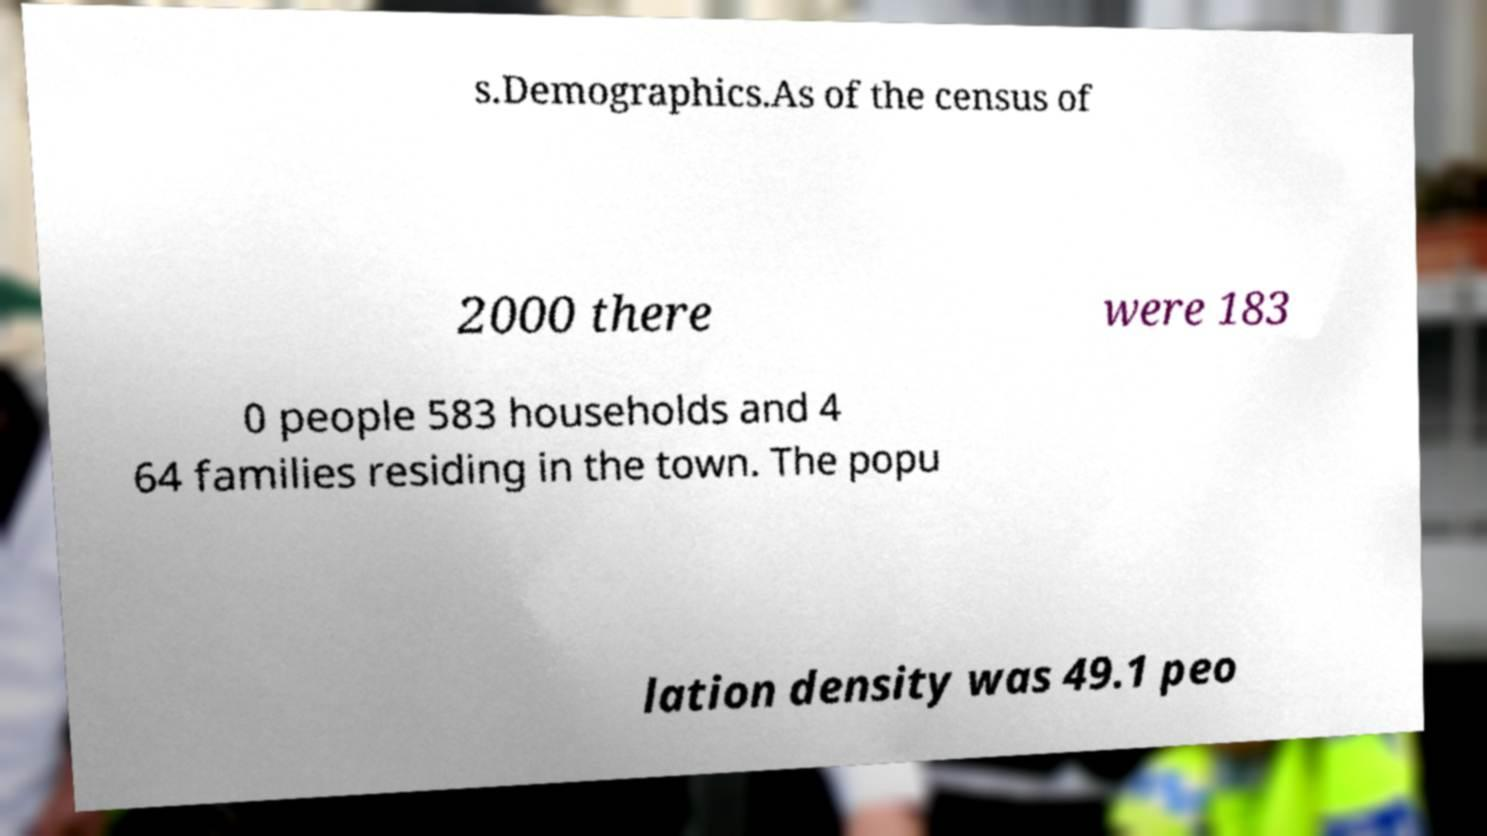What messages or text are displayed in this image? I need them in a readable, typed format. s.Demographics.As of the census of 2000 there were 183 0 people 583 households and 4 64 families residing in the town. The popu lation density was 49.1 peo 